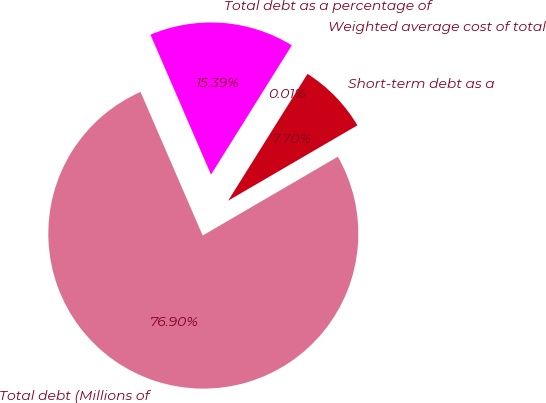Convert chart to OTSL. <chart><loc_0><loc_0><loc_500><loc_500><pie_chart><fcel>Total debt (Millions of<fcel>Short-term debt as a<fcel>Weighted average cost of total<fcel>Total debt as a percentage of<nl><fcel>76.9%<fcel>7.7%<fcel>0.01%<fcel>15.39%<nl></chart> 